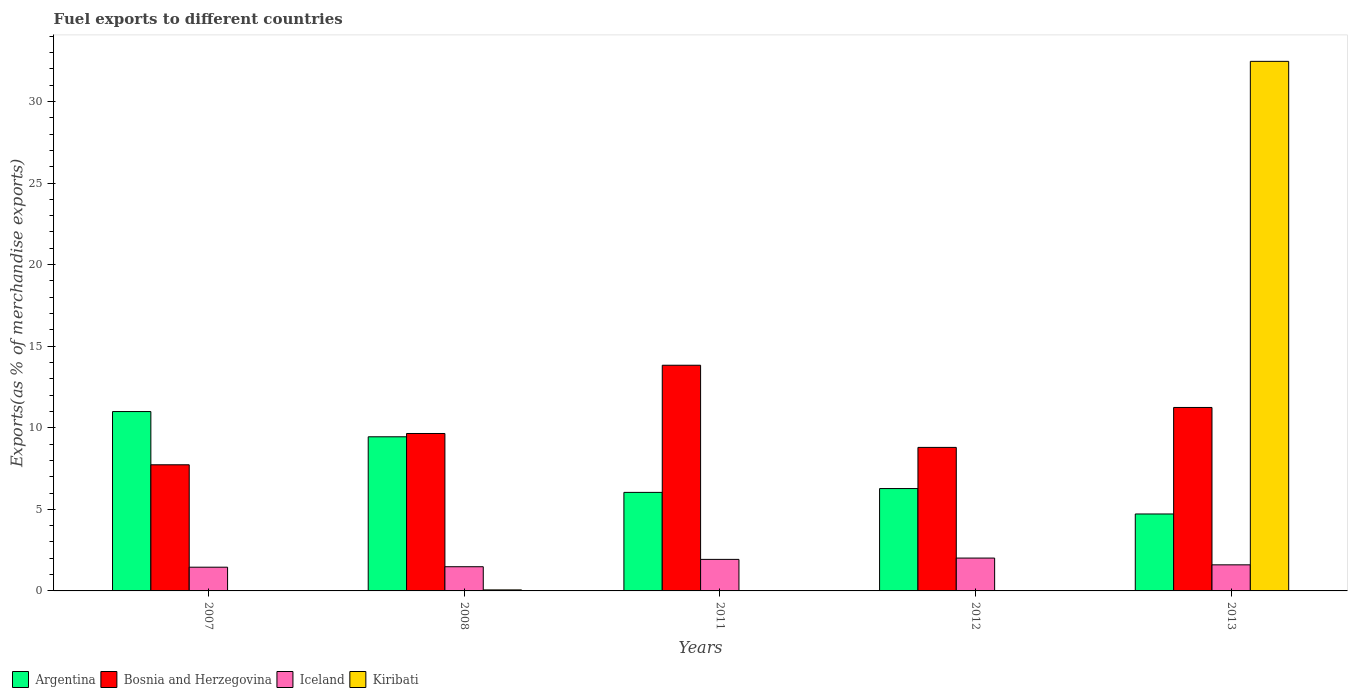How many bars are there on the 3rd tick from the left?
Your answer should be compact. 4. How many bars are there on the 5th tick from the right?
Your response must be concise. 4. What is the percentage of exports to different countries in Argentina in 2007?
Provide a short and direct response. 10.99. Across all years, what is the maximum percentage of exports to different countries in Kiribati?
Provide a succinct answer. 32.46. Across all years, what is the minimum percentage of exports to different countries in Kiribati?
Your answer should be very brief. 0. In which year was the percentage of exports to different countries in Bosnia and Herzegovina maximum?
Your response must be concise. 2011. What is the total percentage of exports to different countries in Bosnia and Herzegovina in the graph?
Provide a succinct answer. 51.25. What is the difference between the percentage of exports to different countries in Iceland in 2008 and that in 2013?
Offer a terse response. -0.12. What is the difference between the percentage of exports to different countries in Kiribati in 2008 and the percentage of exports to different countries in Argentina in 2007?
Provide a succinct answer. -10.93. What is the average percentage of exports to different countries in Bosnia and Herzegovina per year?
Give a very brief answer. 10.25. In the year 2012, what is the difference between the percentage of exports to different countries in Kiribati and percentage of exports to different countries in Iceland?
Keep it short and to the point. -2.01. What is the ratio of the percentage of exports to different countries in Kiribati in 2011 to that in 2013?
Offer a very short reply. 3.583364085658385e-6. What is the difference between the highest and the second highest percentage of exports to different countries in Argentina?
Your answer should be very brief. 1.55. What is the difference between the highest and the lowest percentage of exports to different countries in Iceland?
Your answer should be compact. 0.56. In how many years, is the percentage of exports to different countries in Bosnia and Herzegovina greater than the average percentage of exports to different countries in Bosnia and Herzegovina taken over all years?
Provide a succinct answer. 2. Is the sum of the percentage of exports to different countries in Iceland in 2007 and 2008 greater than the maximum percentage of exports to different countries in Argentina across all years?
Provide a short and direct response. No. What does the 4th bar from the left in 2012 represents?
Your answer should be compact. Kiribati. What does the 3rd bar from the right in 2012 represents?
Offer a terse response. Bosnia and Herzegovina. How many bars are there?
Your answer should be compact. 20. What is the difference between two consecutive major ticks on the Y-axis?
Your response must be concise. 5. How many legend labels are there?
Give a very brief answer. 4. How are the legend labels stacked?
Make the answer very short. Horizontal. What is the title of the graph?
Provide a short and direct response. Fuel exports to different countries. What is the label or title of the Y-axis?
Give a very brief answer. Exports(as % of merchandise exports). What is the Exports(as % of merchandise exports) in Argentina in 2007?
Offer a very short reply. 10.99. What is the Exports(as % of merchandise exports) of Bosnia and Herzegovina in 2007?
Offer a very short reply. 7.73. What is the Exports(as % of merchandise exports) of Iceland in 2007?
Keep it short and to the point. 1.45. What is the Exports(as % of merchandise exports) of Kiribati in 2007?
Provide a short and direct response. 0. What is the Exports(as % of merchandise exports) in Argentina in 2008?
Provide a short and direct response. 9.45. What is the Exports(as % of merchandise exports) of Bosnia and Herzegovina in 2008?
Give a very brief answer. 9.65. What is the Exports(as % of merchandise exports) of Iceland in 2008?
Your response must be concise. 1.48. What is the Exports(as % of merchandise exports) in Kiribati in 2008?
Offer a very short reply. 0.06. What is the Exports(as % of merchandise exports) of Argentina in 2011?
Your answer should be compact. 6.04. What is the Exports(as % of merchandise exports) in Bosnia and Herzegovina in 2011?
Offer a terse response. 13.83. What is the Exports(as % of merchandise exports) of Iceland in 2011?
Your answer should be compact. 1.93. What is the Exports(as % of merchandise exports) in Kiribati in 2011?
Give a very brief answer. 0. What is the Exports(as % of merchandise exports) in Argentina in 2012?
Provide a short and direct response. 6.27. What is the Exports(as % of merchandise exports) of Bosnia and Herzegovina in 2012?
Provide a succinct answer. 8.8. What is the Exports(as % of merchandise exports) in Iceland in 2012?
Your answer should be very brief. 2.01. What is the Exports(as % of merchandise exports) of Kiribati in 2012?
Keep it short and to the point. 0. What is the Exports(as % of merchandise exports) in Argentina in 2013?
Give a very brief answer. 4.72. What is the Exports(as % of merchandise exports) of Bosnia and Herzegovina in 2013?
Keep it short and to the point. 11.24. What is the Exports(as % of merchandise exports) in Iceland in 2013?
Your response must be concise. 1.6. What is the Exports(as % of merchandise exports) of Kiribati in 2013?
Make the answer very short. 32.46. Across all years, what is the maximum Exports(as % of merchandise exports) of Argentina?
Keep it short and to the point. 10.99. Across all years, what is the maximum Exports(as % of merchandise exports) of Bosnia and Herzegovina?
Your answer should be very brief. 13.83. Across all years, what is the maximum Exports(as % of merchandise exports) of Iceland?
Provide a short and direct response. 2.01. Across all years, what is the maximum Exports(as % of merchandise exports) of Kiribati?
Offer a terse response. 32.46. Across all years, what is the minimum Exports(as % of merchandise exports) in Argentina?
Provide a short and direct response. 4.72. Across all years, what is the minimum Exports(as % of merchandise exports) in Bosnia and Herzegovina?
Offer a very short reply. 7.73. Across all years, what is the minimum Exports(as % of merchandise exports) of Iceland?
Provide a short and direct response. 1.45. Across all years, what is the minimum Exports(as % of merchandise exports) of Kiribati?
Provide a short and direct response. 0. What is the total Exports(as % of merchandise exports) of Argentina in the graph?
Provide a succinct answer. 37.47. What is the total Exports(as % of merchandise exports) in Bosnia and Herzegovina in the graph?
Make the answer very short. 51.25. What is the total Exports(as % of merchandise exports) of Iceland in the graph?
Give a very brief answer. 8.48. What is the total Exports(as % of merchandise exports) in Kiribati in the graph?
Offer a very short reply. 32.52. What is the difference between the Exports(as % of merchandise exports) of Argentina in 2007 and that in 2008?
Offer a very short reply. 1.55. What is the difference between the Exports(as % of merchandise exports) of Bosnia and Herzegovina in 2007 and that in 2008?
Offer a terse response. -1.92. What is the difference between the Exports(as % of merchandise exports) in Iceland in 2007 and that in 2008?
Make the answer very short. -0.03. What is the difference between the Exports(as % of merchandise exports) of Kiribati in 2007 and that in 2008?
Offer a very short reply. -0.06. What is the difference between the Exports(as % of merchandise exports) of Argentina in 2007 and that in 2011?
Your response must be concise. 4.95. What is the difference between the Exports(as % of merchandise exports) in Bosnia and Herzegovina in 2007 and that in 2011?
Provide a short and direct response. -6.1. What is the difference between the Exports(as % of merchandise exports) in Iceland in 2007 and that in 2011?
Provide a succinct answer. -0.48. What is the difference between the Exports(as % of merchandise exports) of Argentina in 2007 and that in 2012?
Your answer should be compact. 4.72. What is the difference between the Exports(as % of merchandise exports) of Bosnia and Herzegovina in 2007 and that in 2012?
Provide a short and direct response. -1.07. What is the difference between the Exports(as % of merchandise exports) of Iceland in 2007 and that in 2012?
Offer a terse response. -0.56. What is the difference between the Exports(as % of merchandise exports) of Kiribati in 2007 and that in 2012?
Keep it short and to the point. 0. What is the difference between the Exports(as % of merchandise exports) in Argentina in 2007 and that in 2013?
Keep it short and to the point. 6.28. What is the difference between the Exports(as % of merchandise exports) of Bosnia and Herzegovina in 2007 and that in 2013?
Offer a very short reply. -3.51. What is the difference between the Exports(as % of merchandise exports) in Iceland in 2007 and that in 2013?
Give a very brief answer. -0.15. What is the difference between the Exports(as % of merchandise exports) in Kiribati in 2007 and that in 2013?
Keep it short and to the point. -32.46. What is the difference between the Exports(as % of merchandise exports) of Argentina in 2008 and that in 2011?
Provide a succinct answer. 3.41. What is the difference between the Exports(as % of merchandise exports) in Bosnia and Herzegovina in 2008 and that in 2011?
Ensure brevity in your answer.  -4.18. What is the difference between the Exports(as % of merchandise exports) of Iceland in 2008 and that in 2011?
Provide a short and direct response. -0.45. What is the difference between the Exports(as % of merchandise exports) of Kiribati in 2008 and that in 2011?
Provide a succinct answer. 0.06. What is the difference between the Exports(as % of merchandise exports) in Argentina in 2008 and that in 2012?
Give a very brief answer. 3.17. What is the difference between the Exports(as % of merchandise exports) in Bosnia and Herzegovina in 2008 and that in 2012?
Your answer should be very brief. 0.85. What is the difference between the Exports(as % of merchandise exports) of Iceland in 2008 and that in 2012?
Offer a very short reply. -0.53. What is the difference between the Exports(as % of merchandise exports) of Kiribati in 2008 and that in 2012?
Give a very brief answer. 0.06. What is the difference between the Exports(as % of merchandise exports) in Argentina in 2008 and that in 2013?
Offer a terse response. 4.73. What is the difference between the Exports(as % of merchandise exports) of Bosnia and Herzegovina in 2008 and that in 2013?
Your answer should be compact. -1.6. What is the difference between the Exports(as % of merchandise exports) of Iceland in 2008 and that in 2013?
Provide a succinct answer. -0.12. What is the difference between the Exports(as % of merchandise exports) in Kiribati in 2008 and that in 2013?
Provide a short and direct response. -32.4. What is the difference between the Exports(as % of merchandise exports) in Argentina in 2011 and that in 2012?
Keep it short and to the point. -0.23. What is the difference between the Exports(as % of merchandise exports) of Bosnia and Herzegovina in 2011 and that in 2012?
Ensure brevity in your answer.  5.04. What is the difference between the Exports(as % of merchandise exports) of Iceland in 2011 and that in 2012?
Your response must be concise. -0.08. What is the difference between the Exports(as % of merchandise exports) in Kiribati in 2011 and that in 2012?
Your answer should be compact. -0. What is the difference between the Exports(as % of merchandise exports) of Argentina in 2011 and that in 2013?
Make the answer very short. 1.32. What is the difference between the Exports(as % of merchandise exports) of Bosnia and Herzegovina in 2011 and that in 2013?
Make the answer very short. 2.59. What is the difference between the Exports(as % of merchandise exports) of Iceland in 2011 and that in 2013?
Your answer should be very brief. 0.33. What is the difference between the Exports(as % of merchandise exports) in Kiribati in 2011 and that in 2013?
Offer a terse response. -32.46. What is the difference between the Exports(as % of merchandise exports) of Argentina in 2012 and that in 2013?
Make the answer very short. 1.56. What is the difference between the Exports(as % of merchandise exports) in Bosnia and Herzegovina in 2012 and that in 2013?
Provide a succinct answer. -2.45. What is the difference between the Exports(as % of merchandise exports) of Iceland in 2012 and that in 2013?
Your answer should be compact. 0.41. What is the difference between the Exports(as % of merchandise exports) of Kiribati in 2012 and that in 2013?
Keep it short and to the point. -32.46. What is the difference between the Exports(as % of merchandise exports) in Argentina in 2007 and the Exports(as % of merchandise exports) in Bosnia and Herzegovina in 2008?
Make the answer very short. 1.35. What is the difference between the Exports(as % of merchandise exports) of Argentina in 2007 and the Exports(as % of merchandise exports) of Iceland in 2008?
Your answer should be very brief. 9.51. What is the difference between the Exports(as % of merchandise exports) in Argentina in 2007 and the Exports(as % of merchandise exports) in Kiribati in 2008?
Provide a short and direct response. 10.93. What is the difference between the Exports(as % of merchandise exports) of Bosnia and Herzegovina in 2007 and the Exports(as % of merchandise exports) of Iceland in 2008?
Provide a short and direct response. 6.25. What is the difference between the Exports(as % of merchandise exports) in Bosnia and Herzegovina in 2007 and the Exports(as % of merchandise exports) in Kiribati in 2008?
Ensure brevity in your answer.  7.67. What is the difference between the Exports(as % of merchandise exports) of Iceland in 2007 and the Exports(as % of merchandise exports) of Kiribati in 2008?
Ensure brevity in your answer.  1.39. What is the difference between the Exports(as % of merchandise exports) of Argentina in 2007 and the Exports(as % of merchandise exports) of Bosnia and Herzegovina in 2011?
Give a very brief answer. -2.84. What is the difference between the Exports(as % of merchandise exports) of Argentina in 2007 and the Exports(as % of merchandise exports) of Iceland in 2011?
Keep it short and to the point. 9.06. What is the difference between the Exports(as % of merchandise exports) of Argentina in 2007 and the Exports(as % of merchandise exports) of Kiribati in 2011?
Your answer should be compact. 10.99. What is the difference between the Exports(as % of merchandise exports) in Bosnia and Herzegovina in 2007 and the Exports(as % of merchandise exports) in Iceland in 2011?
Provide a succinct answer. 5.8. What is the difference between the Exports(as % of merchandise exports) of Bosnia and Herzegovina in 2007 and the Exports(as % of merchandise exports) of Kiribati in 2011?
Offer a terse response. 7.73. What is the difference between the Exports(as % of merchandise exports) in Iceland in 2007 and the Exports(as % of merchandise exports) in Kiribati in 2011?
Ensure brevity in your answer.  1.45. What is the difference between the Exports(as % of merchandise exports) of Argentina in 2007 and the Exports(as % of merchandise exports) of Bosnia and Herzegovina in 2012?
Offer a terse response. 2.2. What is the difference between the Exports(as % of merchandise exports) of Argentina in 2007 and the Exports(as % of merchandise exports) of Iceland in 2012?
Your answer should be compact. 8.98. What is the difference between the Exports(as % of merchandise exports) of Argentina in 2007 and the Exports(as % of merchandise exports) of Kiribati in 2012?
Give a very brief answer. 10.99. What is the difference between the Exports(as % of merchandise exports) in Bosnia and Herzegovina in 2007 and the Exports(as % of merchandise exports) in Iceland in 2012?
Your response must be concise. 5.72. What is the difference between the Exports(as % of merchandise exports) in Bosnia and Herzegovina in 2007 and the Exports(as % of merchandise exports) in Kiribati in 2012?
Provide a succinct answer. 7.73. What is the difference between the Exports(as % of merchandise exports) in Iceland in 2007 and the Exports(as % of merchandise exports) in Kiribati in 2012?
Offer a terse response. 1.45. What is the difference between the Exports(as % of merchandise exports) of Argentina in 2007 and the Exports(as % of merchandise exports) of Bosnia and Herzegovina in 2013?
Give a very brief answer. -0.25. What is the difference between the Exports(as % of merchandise exports) of Argentina in 2007 and the Exports(as % of merchandise exports) of Iceland in 2013?
Offer a terse response. 9.39. What is the difference between the Exports(as % of merchandise exports) in Argentina in 2007 and the Exports(as % of merchandise exports) in Kiribati in 2013?
Your answer should be compact. -21.46. What is the difference between the Exports(as % of merchandise exports) of Bosnia and Herzegovina in 2007 and the Exports(as % of merchandise exports) of Iceland in 2013?
Provide a short and direct response. 6.13. What is the difference between the Exports(as % of merchandise exports) of Bosnia and Herzegovina in 2007 and the Exports(as % of merchandise exports) of Kiribati in 2013?
Ensure brevity in your answer.  -24.73. What is the difference between the Exports(as % of merchandise exports) in Iceland in 2007 and the Exports(as % of merchandise exports) in Kiribati in 2013?
Provide a short and direct response. -31. What is the difference between the Exports(as % of merchandise exports) in Argentina in 2008 and the Exports(as % of merchandise exports) in Bosnia and Herzegovina in 2011?
Make the answer very short. -4.39. What is the difference between the Exports(as % of merchandise exports) of Argentina in 2008 and the Exports(as % of merchandise exports) of Iceland in 2011?
Your answer should be compact. 7.51. What is the difference between the Exports(as % of merchandise exports) in Argentina in 2008 and the Exports(as % of merchandise exports) in Kiribati in 2011?
Provide a short and direct response. 9.45. What is the difference between the Exports(as % of merchandise exports) in Bosnia and Herzegovina in 2008 and the Exports(as % of merchandise exports) in Iceland in 2011?
Your answer should be compact. 7.72. What is the difference between the Exports(as % of merchandise exports) in Bosnia and Herzegovina in 2008 and the Exports(as % of merchandise exports) in Kiribati in 2011?
Offer a terse response. 9.65. What is the difference between the Exports(as % of merchandise exports) in Iceland in 2008 and the Exports(as % of merchandise exports) in Kiribati in 2011?
Your response must be concise. 1.48. What is the difference between the Exports(as % of merchandise exports) of Argentina in 2008 and the Exports(as % of merchandise exports) of Bosnia and Herzegovina in 2012?
Ensure brevity in your answer.  0.65. What is the difference between the Exports(as % of merchandise exports) in Argentina in 2008 and the Exports(as % of merchandise exports) in Iceland in 2012?
Provide a succinct answer. 7.43. What is the difference between the Exports(as % of merchandise exports) of Argentina in 2008 and the Exports(as % of merchandise exports) of Kiribati in 2012?
Give a very brief answer. 9.45. What is the difference between the Exports(as % of merchandise exports) of Bosnia and Herzegovina in 2008 and the Exports(as % of merchandise exports) of Iceland in 2012?
Offer a very short reply. 7.64. What is the difference between the Exports(as % of merchandise exports) in Bosnia and Herzegovina in 2008 and the Exports(as % of merchandise exports) in Kiribati in 2012?
Provide a short and direct response. 9.65. What is the difference between the Exports(as % of merchandise exports) in Iceland in 2008 and the Exports(as % of merchandise exports) in Kiribati in 2012?
Provide a short and direct response. 1.48. What is the difference between the Exports(as % of merchandise exports) in Argentina in 2008 and the Exports(as % of merchandise exports) in Bosnia and Herzegovina in 2013?
Keep it short and to the point. -1.8. What is the difference between the Exports(as % of merchandise exports) of Argentina in 2008 and the Exports(as % of merchandise exports) of Iceland in 2013?
Your response must be concise. 7.85. What is the difference between the Exports(as % of merchandise exports) in Argentina in 2008 and the Exports(as % of merchandise exports) in Kiribati in 2013?
Give a very brief answer. -23.01. What is the difference between the Exports(as % of merchandise exports) of Bosnia and Herzegovina in 2008 and the Exports(as % of merchandise exports) of Iceland in 2013?
Offer a terse response. 8.05. What is the difference between the Exports(as % of merchandise exports) in Bosnia and Herzegovina in 2008 and the Exports(as % of merchandise exports) in Kiribati in 2013?
Your response must be concise. -22.81. What is the difference between the Exports(as % of merchandise exports) of Iceland in 2008 and the Exports(as % of merchandise exports) of Kiribati in 2013?
Ensure brevity in your answer.  -30.98. What is the difference between the Exports(as % of merchandise exports) of Argentina in 2011 and the Exports(as % of merchandise exports) of Bosnia and Herzegovina in 2012?
Provide a short and direct response. -2.76. What is the difference between the Exports(as % of merchandise exports) of Argentina in 2011 and the Exports(as % of merchandise exports) of Iceland in 2012?
Offer a very short reply. 4.03. What is the difference between the Exports(as % of merchandise exports) in Argentina in 2011 and the Exports(as % of merchandise exports) in Kiribati in 2012?
Your answer should be compact. 6.04. What is the difference between the Exports(as % of merchandise exports) in Bosnia and Herzegovina in 2011 and the Exports(as % of merchandise exports) in Iceland in 2012?
Provide a succinct answer. 11.82. What is the difference between the Exports(as % of merchandise exports) of Bosnia and Herzegovina in 2011 and the Exports(as % of merchandise exports) of Kiribati in 2012?
Offer a terse response. 13.83. What is the difference between the Exports(as % of merchandise exports) of Iceland in 2011 and the Exports(as % of merchandise exports) of Kiribati in 2012?
Your response must be concise. 1.93. What is the difference between the Exports(as % of merchandise exports) of Argentina in 2011 and the Exports(as % of merchandise exports) of Bosnia and Herzegovina in 2013?
Make the answer very short. -5.21. What is the difference between the Exports(as % of merchandise exports) of Argentina in 2011 and the Exports(as % of merchandise exports) of Iceland in 2013?
Your answer should be compact. 4.44. What is the difference between the Exports(as % of merchandise exports) in Argentina in 2011 and the Exports(as % of merchandise exports) in Kiribati in 2013?
Your response must be concise. -26.42. What is the difference between the Exports(as % of merchandise exports) of Bosnia and Herzegovina in 2011 and the Exports(as % of merchandise exports) of Iceland in 2013?
Offer a terse response. 12.23. What is the difference between the Exports(as % of merchandise exports) in Bosnia and Herzegovina in 2011 and the Exports(as % of merchandise exports) in Kiribati in 2013?
Offer a terse response. -18.63. What is the difference between the Exports(as % of merchandise exports) in Iceland in 2011 and the Exports(as % of merchandise exports) in Kiribati in 2013?
Offer a terse response. -30.53. What is the difference between the Exports(as % of merchandise exports) in Argentina in 2012 and the Exports(as % of merchandise exports) in Bosnia and Herzegovina in 2013?
Provide a short and direct response. -4.97. What is the difference between the Exports(as % of merchandise exports) in Argentina in 2012 and the Exports(as % of merchandise exports) in Iceland in 2013?
Your answer should be compact. 4.68. What is the difference between the Exports(as % of merchandise exports) of Argentina in 2012 and the Exports(as % of merchandise exports) of Kiribati in 2013?
Your answer should be very brief. -26.18. What is the difference between the Exports(as % of merchandise exports) of Bosnia and Herzegovina in 2012 and the Exports(as % of merchandise exports) of Iceland in 2013?
Give a very brief answer. 7.2. What is the difference between the Exports(as % of merchandise exports) in Bosnia and Herzegovina in 2012 and the Exports(as % of merchandise exports) in Kiribati in 2013?
Provide a succinct answer. -23.66. What is the difference between the Exports(as % of merchandise exports) of Iceland in 2012 and the Exports(as % of merchandise exports) of Kiribati in 2013?
Provide a succinct answer. -30.44. What is the average Exports(as % of merchandise exports) of Argentina per year?
Provide a succinct answer. 7.49. What is the average Exports(as % of merchandise exports) in Bosnia and Herzegovina per year?
Keep it short and to the point. 10.25. What is the average Exports(as % of merchandise exports) of Iceland per year?
Keep it short and to the point. 1.7. What is the average Exports(as % of merchandise exports) in Kiribati per year?
Ensure brevity in your answer.  6.5. In the year 2007, what is the difference between the Exports(as % of merchandise exports) of Argentina and Exports(as % of merchandise exports) of Bosnia and Herzegovina?
Offer a terse response. 3.26. In the year 2007, what is the difference between the Exports(as % of merchandise exports) of Argentina and Exports(as % of merchandise exports) of Iceland?
Make the answer very short. 9.54. In the year 2007, what is the difference between the Exports(as % of merchandise exports) of Argentina and Exports(as % of merchandise exports) of Kiribati?
Make the answer very short. 10.99. In the year 2007, what is the difference between the Exports(as % of merchandise exports) of Bosnia and Herzegovina and Exports(as % of merchandise exports) of Iceland?
Offer a very short reply. 6.28. In the year 2007, what is the difference between the Exports(as % of merchandise exports) in Bosnia and Herzegovina and Exports(as % of merchandise exports) in Kiribati?
Your answer should be compact. 7.73. In the year 2007, what is the difference between the Exports(as % of merchandise exports) of Iceland and Exports(as % of merchandise exports) of Kiribati?
Your answer should be very brief. 1.45. In the year 2008, what is the difference between the Exports(as % of merchandise exports) in Argentina and Exports(as % of merchandise exports) in Bosnia and Herzegovina?
Give a very brief answer. -0.2. In the year 2008, what is the difference between the Exports(as % of merchandise exports) in Argentina and Exports(as % of merchandise exports) in Iceland?
Your answer should be compact. 7.96. In the year 2008, what is the difference between the Exports(as % of merchandise exports) of Argentina and Exports(as % of merchandise exports) of Kiribati?
Make the answer very short. 9.38. In the year 2008, what is the difference between the Exports(as % of merchandise exports) of Bosnia and Herzegovina and Exports(as % of merchandise exports) of Iceland?
Ensure brevity in your answer.  8.17. In the year 2008, what is the difference between the Exports(as % of merchandise exports) in Bosnia and Herzegovina and Exports(as % of merchandise exports) in Kiribati?
Provide a short and direct response. 9.59. In the year 2008, what is the difference between the Exports(as % of merchandise exports) in Iceland and Exports(as % of merchandise exports) in Kiribati?
Keep it short and to the point. 1.42. In the year 2011, what is the difference between the Exports(as % of merchandise exports) of Argentina and Exports(as % of merchandise exports) of Bosnia and Herzegovina?
Your answer should be very brief. -7.79. In the year 2011, what is the difference between the Exports(as % of merchandise exports) in Argentina and Exports(as % of merchandise exports) in Iceland?
Keep it short and to the point. 4.11. In the year 2011, what is the difference between the Exports(as % of merchandise exports) in Argentina and Exports(as % of merchandise exports) in Kiribati?
Ensure brevity in your answer.  6.04. In the year 2011, what is the difference between the Exports(as % of merchandise exports) in Bosnia and Herzegovina and Exports(as % of merchandise exports) in Iceland?
Provide a succinct answer. 11.9. In the year 2011, what is the difference between the Exports(as % of merchandise exports) of Bosnia and Herzegovina and Exports(as % of merchandise exports) of Kiribati?
Ensure brevity in your answer.  13.83. In the year 2011, what is the difference between the Exports(as % of merchandise exports) in Iceland and Exports(as % of merchandise exports) in Kiribati?
Offer a very short reply. 1.93. In the year 2012, what is the difference between the Exports(as % of merchandise exports) in Argentina and Exports(as % of merchandise exports) in Bosnia and Herzegovina?
Provide a short and direct response. -2.52. In the year 2012, what is the difference between the Exports(as % of merchandise exports) of Argentina and Exports(as % of merchandise exports) of Iceland?
Provide a short and direct response. 4.26. In the year 2012, what is the difference between the Exports(as % of merchandise exports) in Argentina and Exports(as % of merchandise exports) in Kiribati?
Your answer should be very brief. 6.27. In the year 2012, what is the difference between the Exports(as % of merchandise exports) in Bosnia and Herzegovina and Exports(as % of merchandise exports) in Iceland?
Your answer should be very brief. 6.78. In the year 2012, what is the difference between the Exports(as % of merchandise exports) in Bosnia and Herzegovina and Exports(as % of merchandise exports) in Kiribati?
Ensure brevity in your answer.  8.8. In the year 2012, what is the difference between the Exports(as % of merchandise exports) of Iceland and Exports(as % of merchandise exports) of Kiribati?
Provide a succinct answer. 2.01. In the year 2013, what is the difference between the Exports(as % of merchandise exports) in Argentina and Exports(as % of merchandise exports) in Bosnia and Herzegovina?
Offer a very short reply. -6.53. In the year 2013, what is the difference between the Exports(as % of merchandise exports) in Argentina and Exports(as % of merchandise exports) in Iceland?
Give a very brief answer. 3.12. In the year 2013, what is the difference between the Exports(as % of merchandise exports) of Argentina and Exports(as % of merchandise exports) of Kiribati?
Your answer should be very brief. -27.74. In the year 2013, what is the difference between the Exports(as % of merchandise exports) in Bosnia and Herzegovina and Exports(as % of merchandise exports) in Iceland?
Offer a terse response. 9.65. In the year 2013, what is the difference between the Exports(as % of merchandise exports) of Bosnia and Herzegovina and Exports(as % of merchandise exports) of Kiribati?
Offer a terse response. -21.21. In the year 2013, what is the difference between the Exports(as % of merchandise exports) of Iceland and Exports(as % of merchandise exports) of Kiribati?
Make the answer very short. -30.86. What is the ratio of the Exports(as % of merchandise exports) of Argentina in 2007 to that in 2008?
Your answer should be very brief. 1.16. What is the ratio of the Exports(as % of merchandise exports) of Bosnia and Herzegovina in 2007 to that in 2008?
Make the answer very short. 0.8. What is the ratio of the Exports(as % of merchandise exports) of Iceland in 2007 to that in 2008?
Offer a terse response. 0.98. What is the ratio of the Exports(as % of merchandise exports) in Kiribati in 2007 to that in 2008?
Provide a short and direct response. 0. What is the ratio of the Exports(as % of merchandise exports) of Argentina in 2007 to that in 2011?
Ensure brevity in your answer.  1.82. What is the ratio of the Exports(as % of merchandise exports) of Bosnia and Herzegovina in 2007 to that in 2011?
Provide a short and direct response. 0.56. What is the ratio of the Exports(as % of merchandise exports) of Iceland in 2007 to that in 2011?
Your response must be concise. 0.75. What is the ratio of the Exports(as % of merchandise exports) in Kiribati in 2007 to that in 2011?
Keep it short and to the point. 2.12. What is the ratio of the Exports(as % of merchandise exports) in Argentina in 2007 to that in 2012?
Give a very brief answer. 1.75. What is the ratio of the Exports(as % of merchandise exports) in Bosnia and Herzegovina in 2007 to that in 2012?
Make the answer very short. 0.88. What is the ratio of the Exports(as % of merchandise exports) of Iceland in 2007 to that in 2012?
Make the answer very short. 0.72. What is the ratio of the Exports(as % of merchandise exports) in Kiribati in 2007 to that in 2012?
Ensure brevity in your answer.  1.43. What is the ratio of the Exports(as % of merchandise exports) of Argentina in 2007 to that in 2013?
Make the answer very short. 2.33. What is the ratio of the Exports(as % of merchandise exports) of Bosnia and Herzegovina in 2007 to that in 2013?
Ensure brevity in your answer.  0.69. What is the ratio of the Exports(as % of merchandise exports) in Iceland in 2007 to that in 2013?
Keep it short and to the point. 0.91. What is the ratio of the Exports(as % of merchandise exports) in Argentina in 2008 to that in 2011?
Give a very brief answer. 1.56. What is the ratio of the Exports(as % of merchandise exports) of Bosnia and Herzegovina in 2008 to that in 2011?
Provide a succinct answer. 0.7. What is the ratio of the Exports(as % of merchandise exports) in Iceland in 2008 to that in 2011?
Keep it short and to the point. 0.77. What is the ratio of the Exports(as % of merchandise exports) in Kiribati in 2008 to that in 2011?
Give a very brief answer. 540.83. What is the ratio of the Exports(as % of merchandise exports) in Argentina in 2008 to that in 2012?
Keep it short and to the point. 1.51. What is the ratio of the Exports(as % of merchandise exports) of Bosnia and Herzegovina in 2008 to that in 2012?
Provide a short and direct response. 1.1. What is the ratio of the Exports(as % of merchandise exports) of Iceland in 2008 to that in 2012?
Ensure brevity in your answer.  0.74. What is the ratio of the Exports(as % of merchandise exports) in Kiribati in 2008 to that in 2012?
Offer a very short reply. 365.82. What is the ratio of the Exports(as % of merchandise exports) in Argentina in 2008 to that in 2013?
Your answer should be very brief. 2. What is the ratio of the Exports(as % of merchandise exports) of Bosnia and Herzegovina in 2008 to that in 2013?
Offer a very short reply. 0.86. What is the ratio of the Exports(as % of merchandise exports) of Iceland in 2008 to that in 2013?
Make the answer very short. 0.93. What is the ratio of the Exports(as % of merchandise exports) in Kiribati in 2008 to that in 2013?
Keep it short and to the point. 0. What is the ratio of the Exports(as % of merchandise exports) of Argentina in 2011 to that in 2012?
Your answer should be very brief. 0.96. What is the ratio of the Exports(as % of merchandise exports) of Bosnia and Herzegovina in 2011 to that in 2012?
Keep it short and to the point. 1.57. What is the ratio of the Exports(as % of merchandise exports) in Iceland in 2011 to that in 2012?
Your response must be concise. 0.96. What is the ratio of the Exports(as % of merchandise exports) in Kiribati in 2011 to that in 2012?
Offer a very short reply. 0.68. What is the ratio of the Exports(as % of merchandise exports) in Argentina in 2011 to that in 2013?
Make the answer very short. 1.28. What is the ratio of the Exports(as % of merchandise exports) of Bosnia and Herzegovina in 2011 to that in 2013?
Provide a succinct answer. 1.23. What is the ratio of the Exports(as % of merchandise exports) in Iceland in 2011 to that in 2013?
Provide a succinct answer. 1.21. What is the ratio of the Exports(as % of merchandise exports) of Kiribati in 2011 to that in 2013?
Give a very brief answer. 0. What is the ratio of the Exports(as % of merchandise exports) in Argentina in 2012 to that in 2013?
Make the answer very short. 1.33. What is the ratio of the Exports(as % of merchandise exports) in Bosnia and Herzegovina in 2012 to that in 2013?
Provide a succinct answer. 0.78. What is the ratio of the Exports(as % of merchandise exports) of Iceland in 2012 to that in 2013?
Ensure brevity in your answer.  1.26. What is the difference between the highest and the second highest Exports(as % of merchandise exports) of Argentina?
Give a very brief answer. 1.55. What is the difference between the highest and the second highest Exports(as % of merchandise exports) in Bosnia and Herzegovina?
Make the answer very short. 2.59. What is the difference between the highest and the second highest Exports(as % of merchandise exports) of Iceland?
Provide a succinct answer. 0.08. What is the difference between the highest and the second highest Exports(as % of merchandise exports) in Kiribati?
Your answer should be very brief. 32.4. What is the difference between the highest and the lowest Exports(as % of merchandise exports) of Argentina?
Make the answer very short. 6.28. What is the difference between the highest and the lowest Exports(as % of merchandise exports) of Bosnia and Herzegovina?
Your answer should be very brief. 6.1. What is the difference between the highest and the lowest Exports(as % of merchandise exports) in Iceland?
Your answer should be very brief. 0.56. What is the difference between the highest and the lowest Exports(as % of merchandise exports) of Kiribati?
Provide a short and direct response. 32.46. 